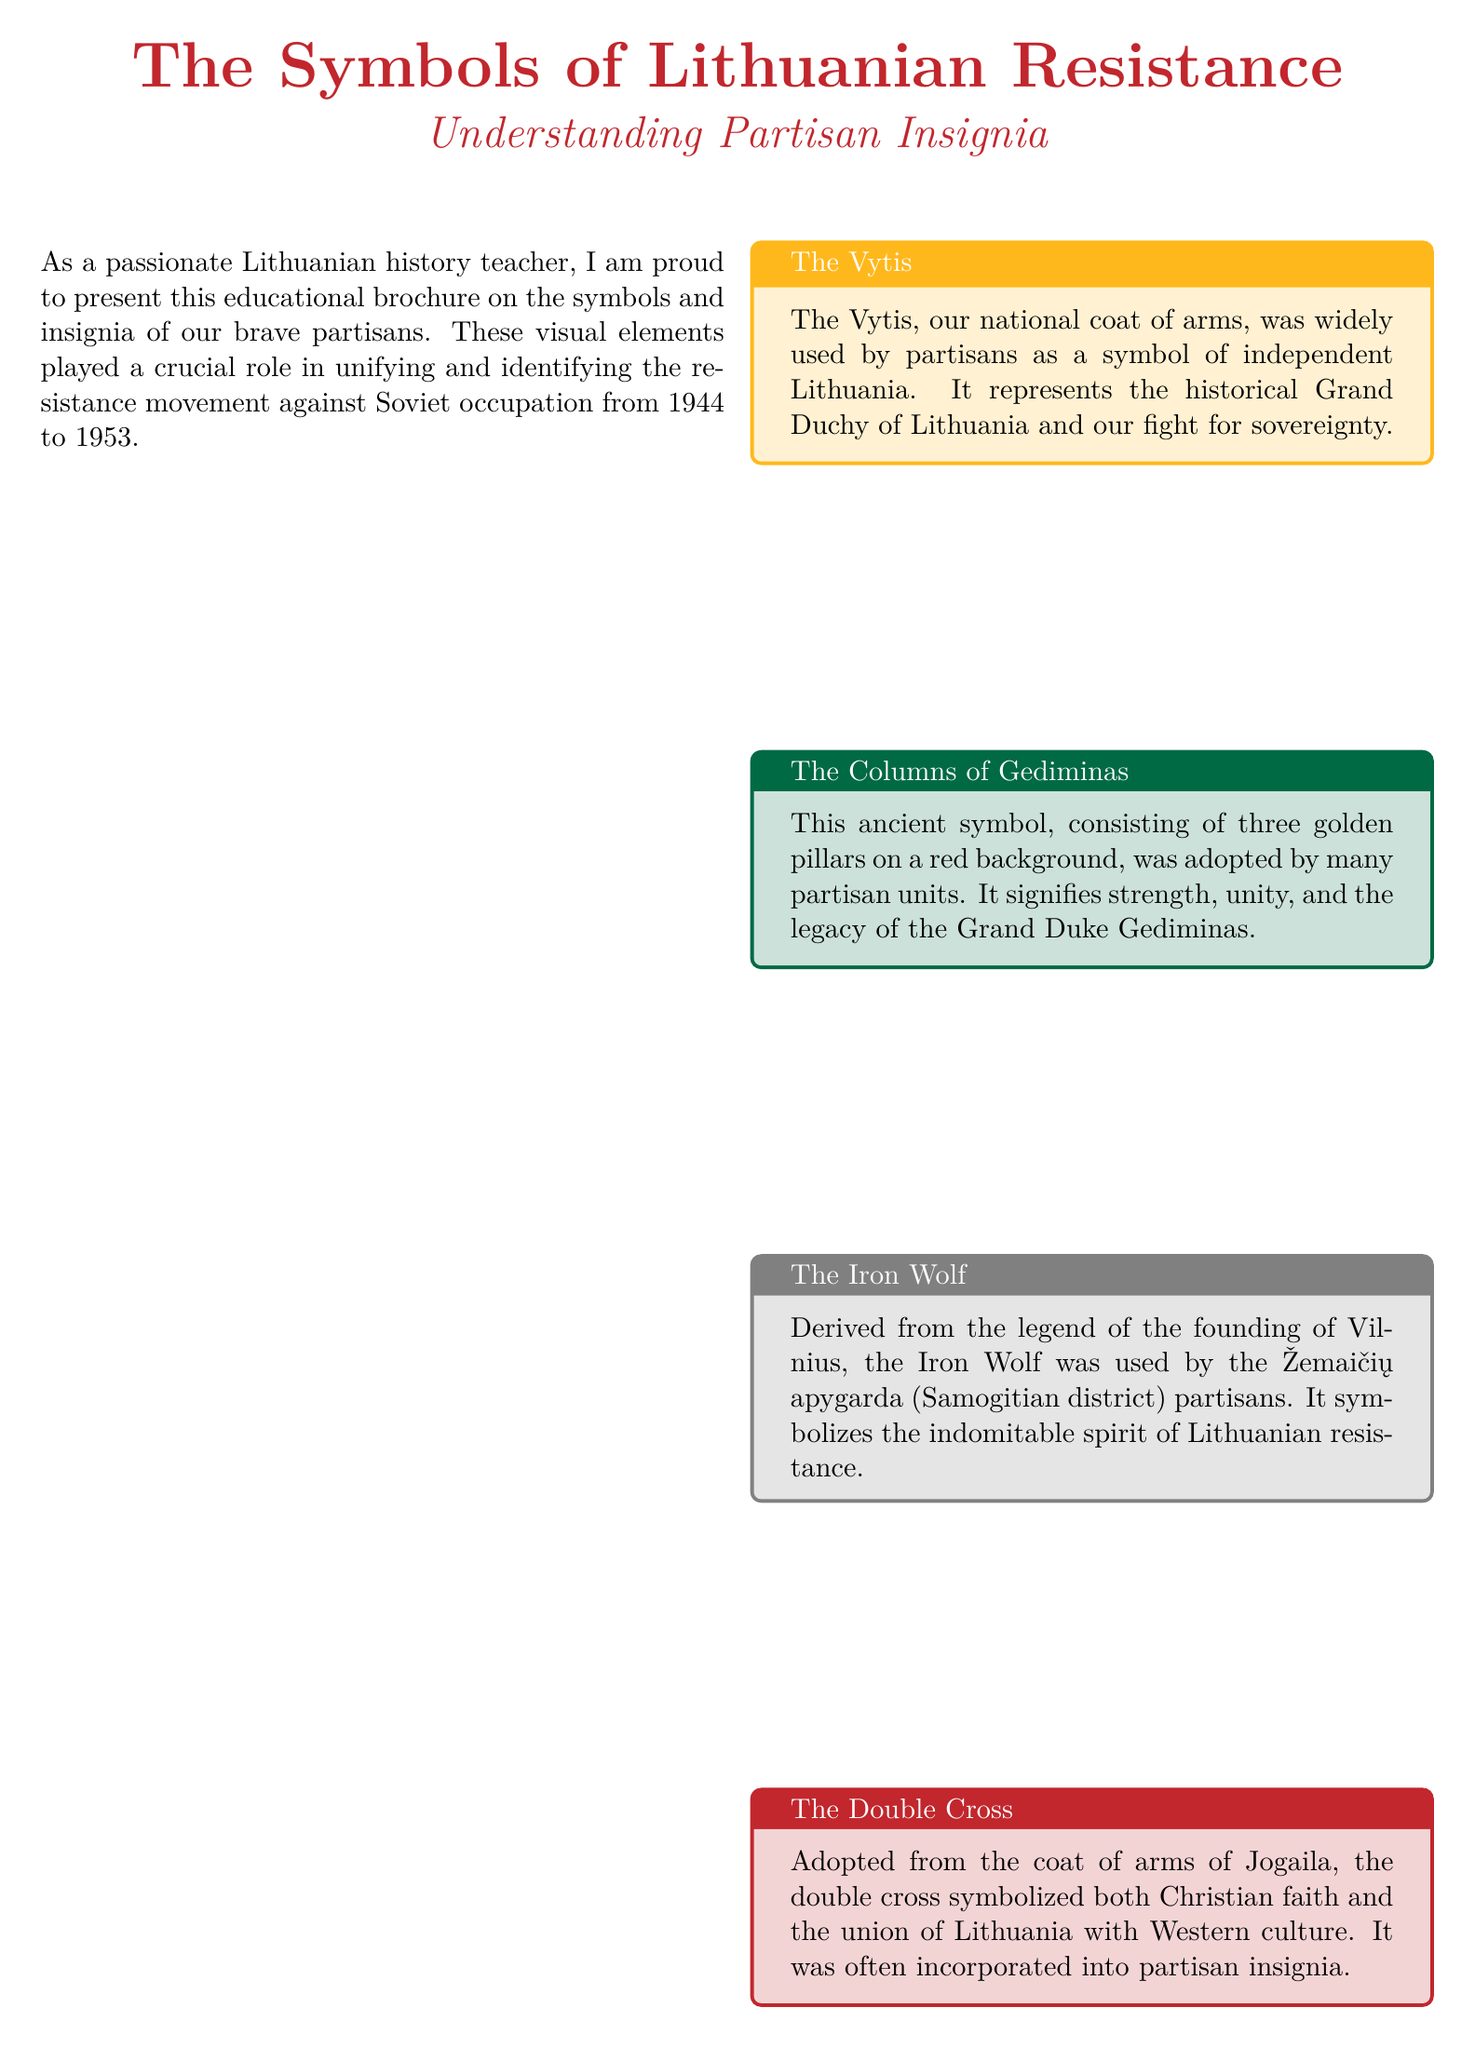What is the title of the brochure? The title of the brochure is prominently displayed at the top, indicating the subject of the document.
Answer: The Symbols of Lithuanian Resistance: Understanding Partisan Insignia Who created this brochure? The author mentions their role and passion for teaching Lithuanian history, specifically related to partisans.
Answer: A Lithuanian history teacher What does the Vytis represent? The content of the section describes the significance of the Vytis in relation to Lithuanian statehood.
Answer: The historical Grand Duchy of Lithuania How many pillars are in the Columns of Gediminas? The description specifies the number of pillars that form this ancient symbol.
Answer: Three What does the Iron Wolf symbolize? The section about the Iron Wolf explains its meaning in the context of Lithuanian resistance.
Answer: The indomitable spirit of Lithuanian resistance What colors are in the Lithuanian flag? The content explains the colors represented in the Lithuanian flag, which also relates to partisan insignia.
Answer: Yellow, green, and red What type of insignia did partisans use for officers? The section on rank insignia describes what was used to signify rank among officers.
Answer: Stars Which district used a bull symbol? The document lists examples of various unit patches and which symbols were associated with specific districts.
Answer: Tauras district Where is the Lithuanian Partisan and Resistance Movement Museum located? The additional resources section provides the location of one of the museums related to the partisan movement.
Answer: Raseiniai 